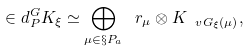Convert formula to latex. <formula><loc_0><loc_0><loc_500><loc_500>\in d _ { P } ^ { G } K _ { \xi } \simeq \bigoplus _ { \mu \in \S P _ { a } } \ r _ { \mu } \otimes K _ { \ v G _ { \xi } ( \mu ) } ,</formula> 